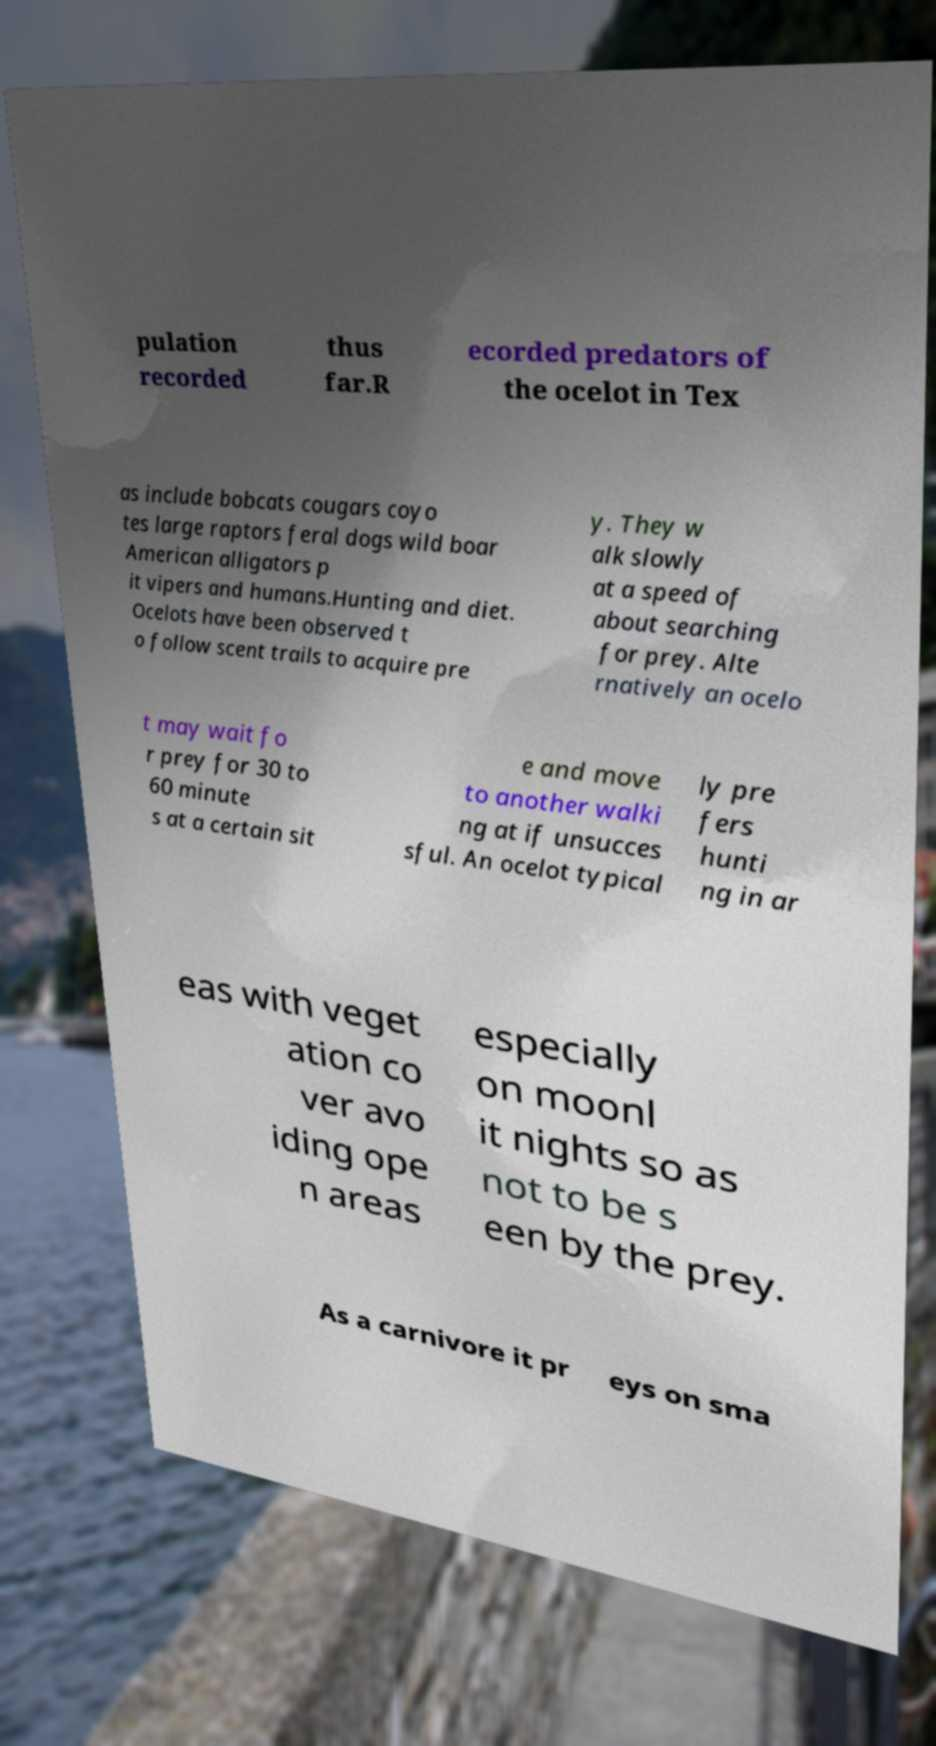For documentation purposes, I need the text within this image transcribed. Could you provide that? pulation recorded thus far.R ecorded predators of the ocelot in Tex as include bobcats cougars coyo tes large raptors feral dogs wild boar American alligators p it vipers and humans.Hunting and diet. Ocelots have been observed t o follow scent trails to acquire pre y. They w alk slowly at a speed of about searching for prey. Alte rnatively an ocelo t may wait fo r prey for 30 to 60 minute s at a certain sit e and move to another walki ng at if unsucces sful. An ocelot typical ly pre fers hunti ng in ar eas with veget ation co ver avo iding ope n areas especially on moonl it nights so as not to be s een by the prey. As a carnivore it pr eys on sma 